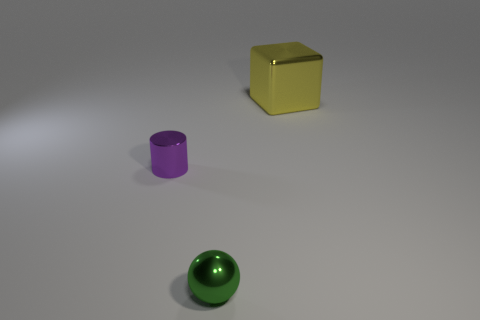Subtract 1 blocks. How many blocks are left? 0 Add 1 balls. How many objects exist? 4 Subtract all balls. How many objects are left? 2 Add 3 cylinders. How many cylinders are left? 4 Add 2 large purple matte spheres. How many large purple matte spheres exist? 2 Subtract 0 blue blocks. How many objects are left? 3 Subtract all brown cylinders. Subtract all green balls. How many cylinders are left? 1 Subtract all big yellow metal things. Subtract all yellow cubes. How many objects are left? 1 